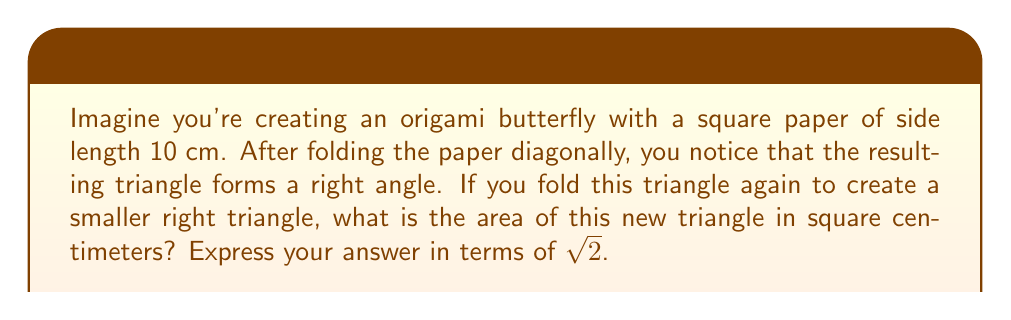Can you answer this question? Let's approach this step-by-step:

1) First, let's visualize the initial square and its diagonal fold:

   [asy]
   unitsize(0.5cm);
   pair A=(0,0), B=(10,0), C=(10,10), D=(0,10);
   draw(A--B--C--D--cycle);
   draw(A--C,dashed);
   label("10 cm",B/2,S);
   label("10 cm",C/2,E);
   [/asy]

2) The diagonal of a square forms two congruent right triangles. The hypotenuse of each triangle is the diagonal of the square.

3) We can find the length of the diagonal using the Pythagorean theorem:
   $$ d^2 = 10^2 + 10^2 = 200 $$
   $$ d = \sqrt{200} = 10\sqrt{2} \text{ cm} $$

4) Now, when we fold this triangle again to create a smaller right triangle, we're essentially creating a triangle similar to the original, but with half the hypotenuse length:

   [asy]
   unitsize(0.5cm);
   pair A=(0,0), B=(10,0), C=(10,10);
   draw(A--B--C--cycle);
   draw((0,0)--(5,5),dashed);
   label("5$\sqrt{2}$ cm",(2.5,2.5),NW);
   [/asy]

5) The hypotenuse of this new triangle is:
   $$ \frac{10\sqrt{2}}{2} = 5\sqrt{2} \text{ cm} $$

6) To find the area of this new triangle, we need its base and height. Since it's similar to the original triangle, its base and height will be half of the original:
   Base = Height = $5$ cm

7) The area of a triangle is given by the formula: $A = \frac{1}{2} \times base \times height$

8) Therefore, the area of our new triangle is:
   $$ A = \frac{1}{2} \times 5 \times 5 = \frac{25}{2} = 12.5 \text{ cm}^2 $$

9) However, we need to express this in terms of $\sqrt{2}$. We can rewrite 12.5 as:
   $$ 12.5 = \frac{25}{2} = \frac{50}{4} = \frac{25\sqrt{2}}{2\sqrt{2}} = \frac{25\sqrt{2}}{2\sqrt{2}} \times \frac{\sqrt{2}}{\sqrt{2}} = \frac{25(\sqrt{2})^2}{4\sqrt{2}} = \frac{25 \times 2}{4\sqrt{2}} = \frac{25}{\sqrt{2}} \text{ cm}^2 $$
Answer: $\frac{25}{\sqrt{2}}$ cm² 